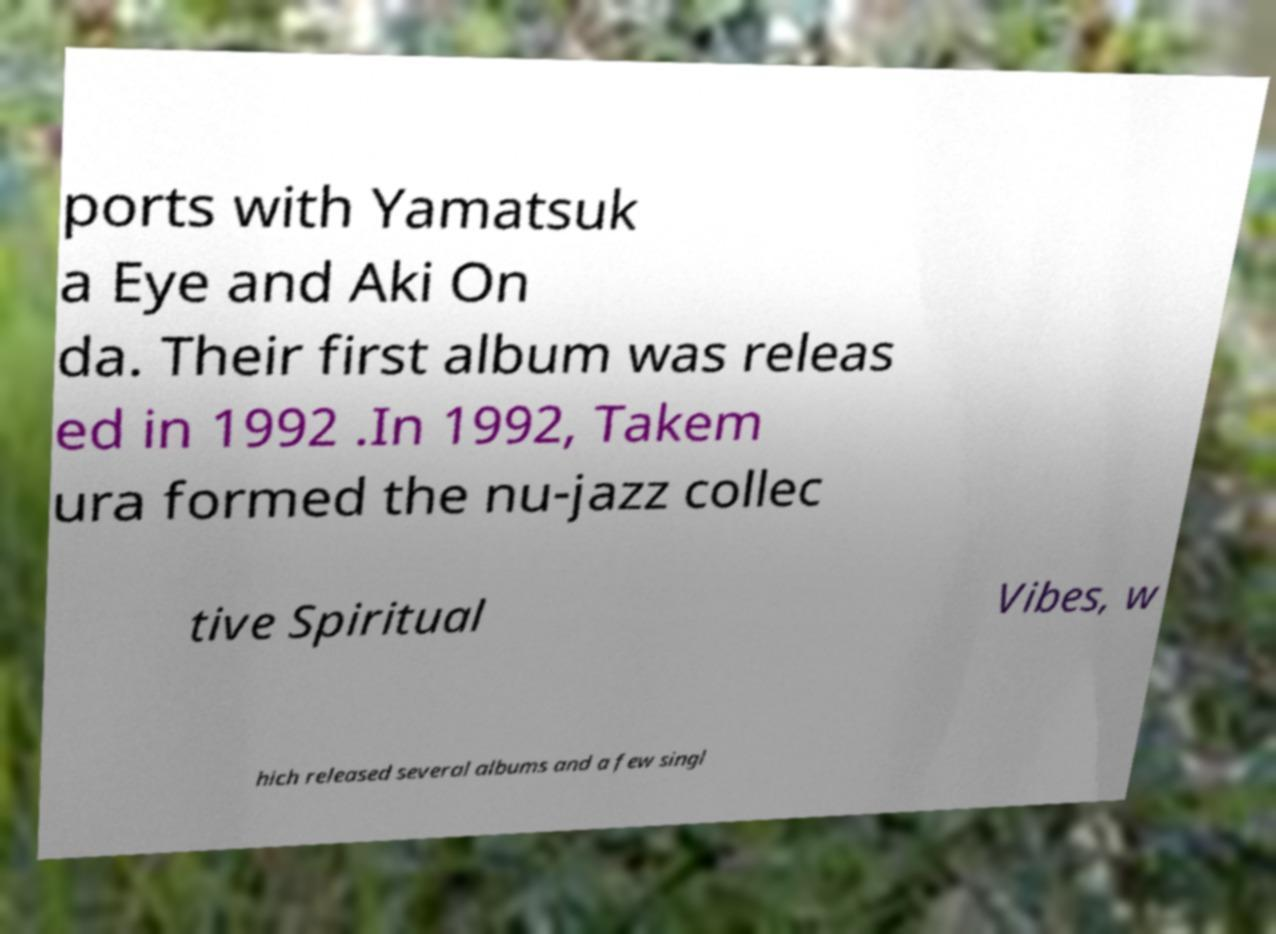For documentation purposes, I need the text within this image transcribed. Could you provide that? ports with Yamatsuk a Eye and Aki On da. Their first album was releas ed in 1992 .In 1992, Takem ura formed the nu-jazz collec tive Spiritual Vibes, w hich released several albums and a few singl 